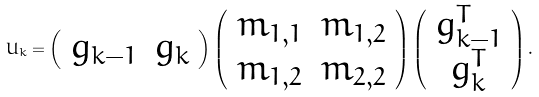<formula> <loc_0><loc_0><loc_500><loc_500>U _ { k } = \left ( \begin{array} { l l } g _ { k - 1 } & g _ { k } \end{array} \right ) \left ( \begin{array} { c c } m _ { 1 , 1 } & m _ { 1 , 2 } \\ m _ { 1 , 2 } & m _ { 2 , 2 } \end{array} \right ) \left ( \begin{array} { c } g _ { k - 1 } ^ { T } \\ g _ { k } ^ { T } \end{array} \right ) .</formula> 